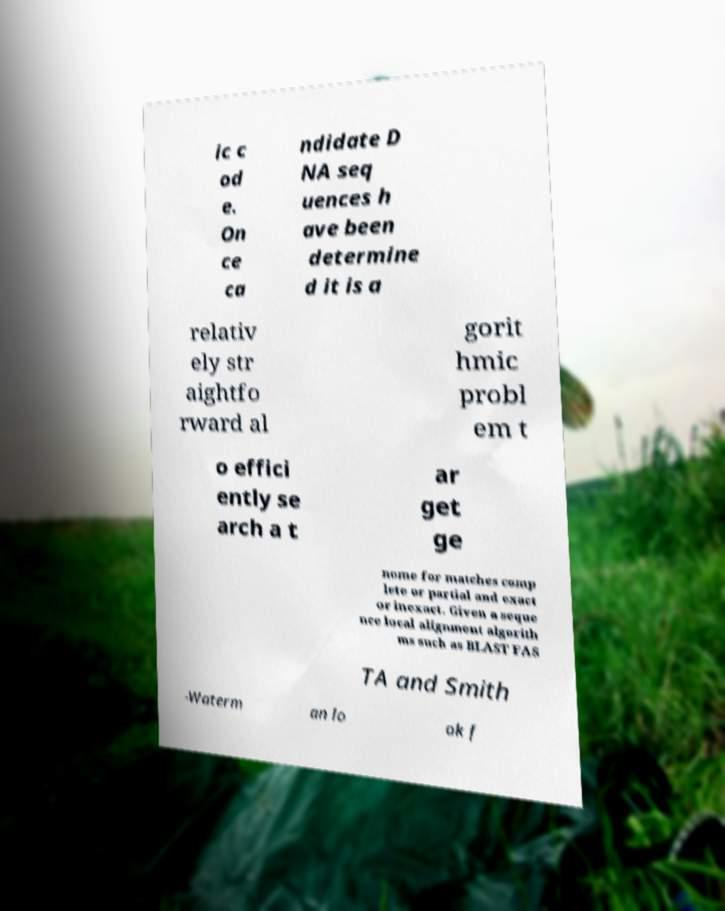I need the written content from this picture converted into text. Can you do that? ic c od e. On ce ca ndidate D NA seq uences h ave been determine d it is a relativ ely str aightfo rward al gorit hmic probl em t o effici ently se arch a t ar get ge nome for matches comp lete or partial and exact or inexact. Given a seque nce local alignment algorith ms such as BLAST FAS TA and Smith -Waterm an lo ok f 